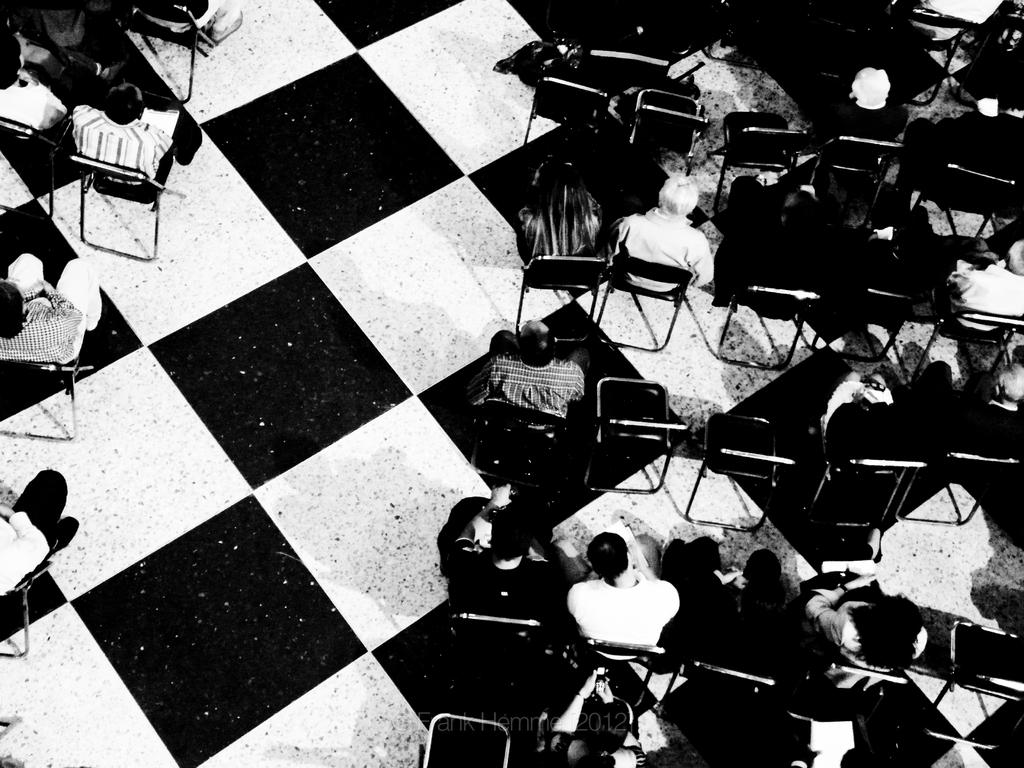What is happening in the image? There is a group of people in the image. What are the people doing in the image? The people are sitting on chairs. Can you describe the floor in the image? The floor has a white and black color pattern. What type of coast can be seen in the image? There is no coast visible in the image; it features a group of people sitting on chairs with a white and black floor pattern. 